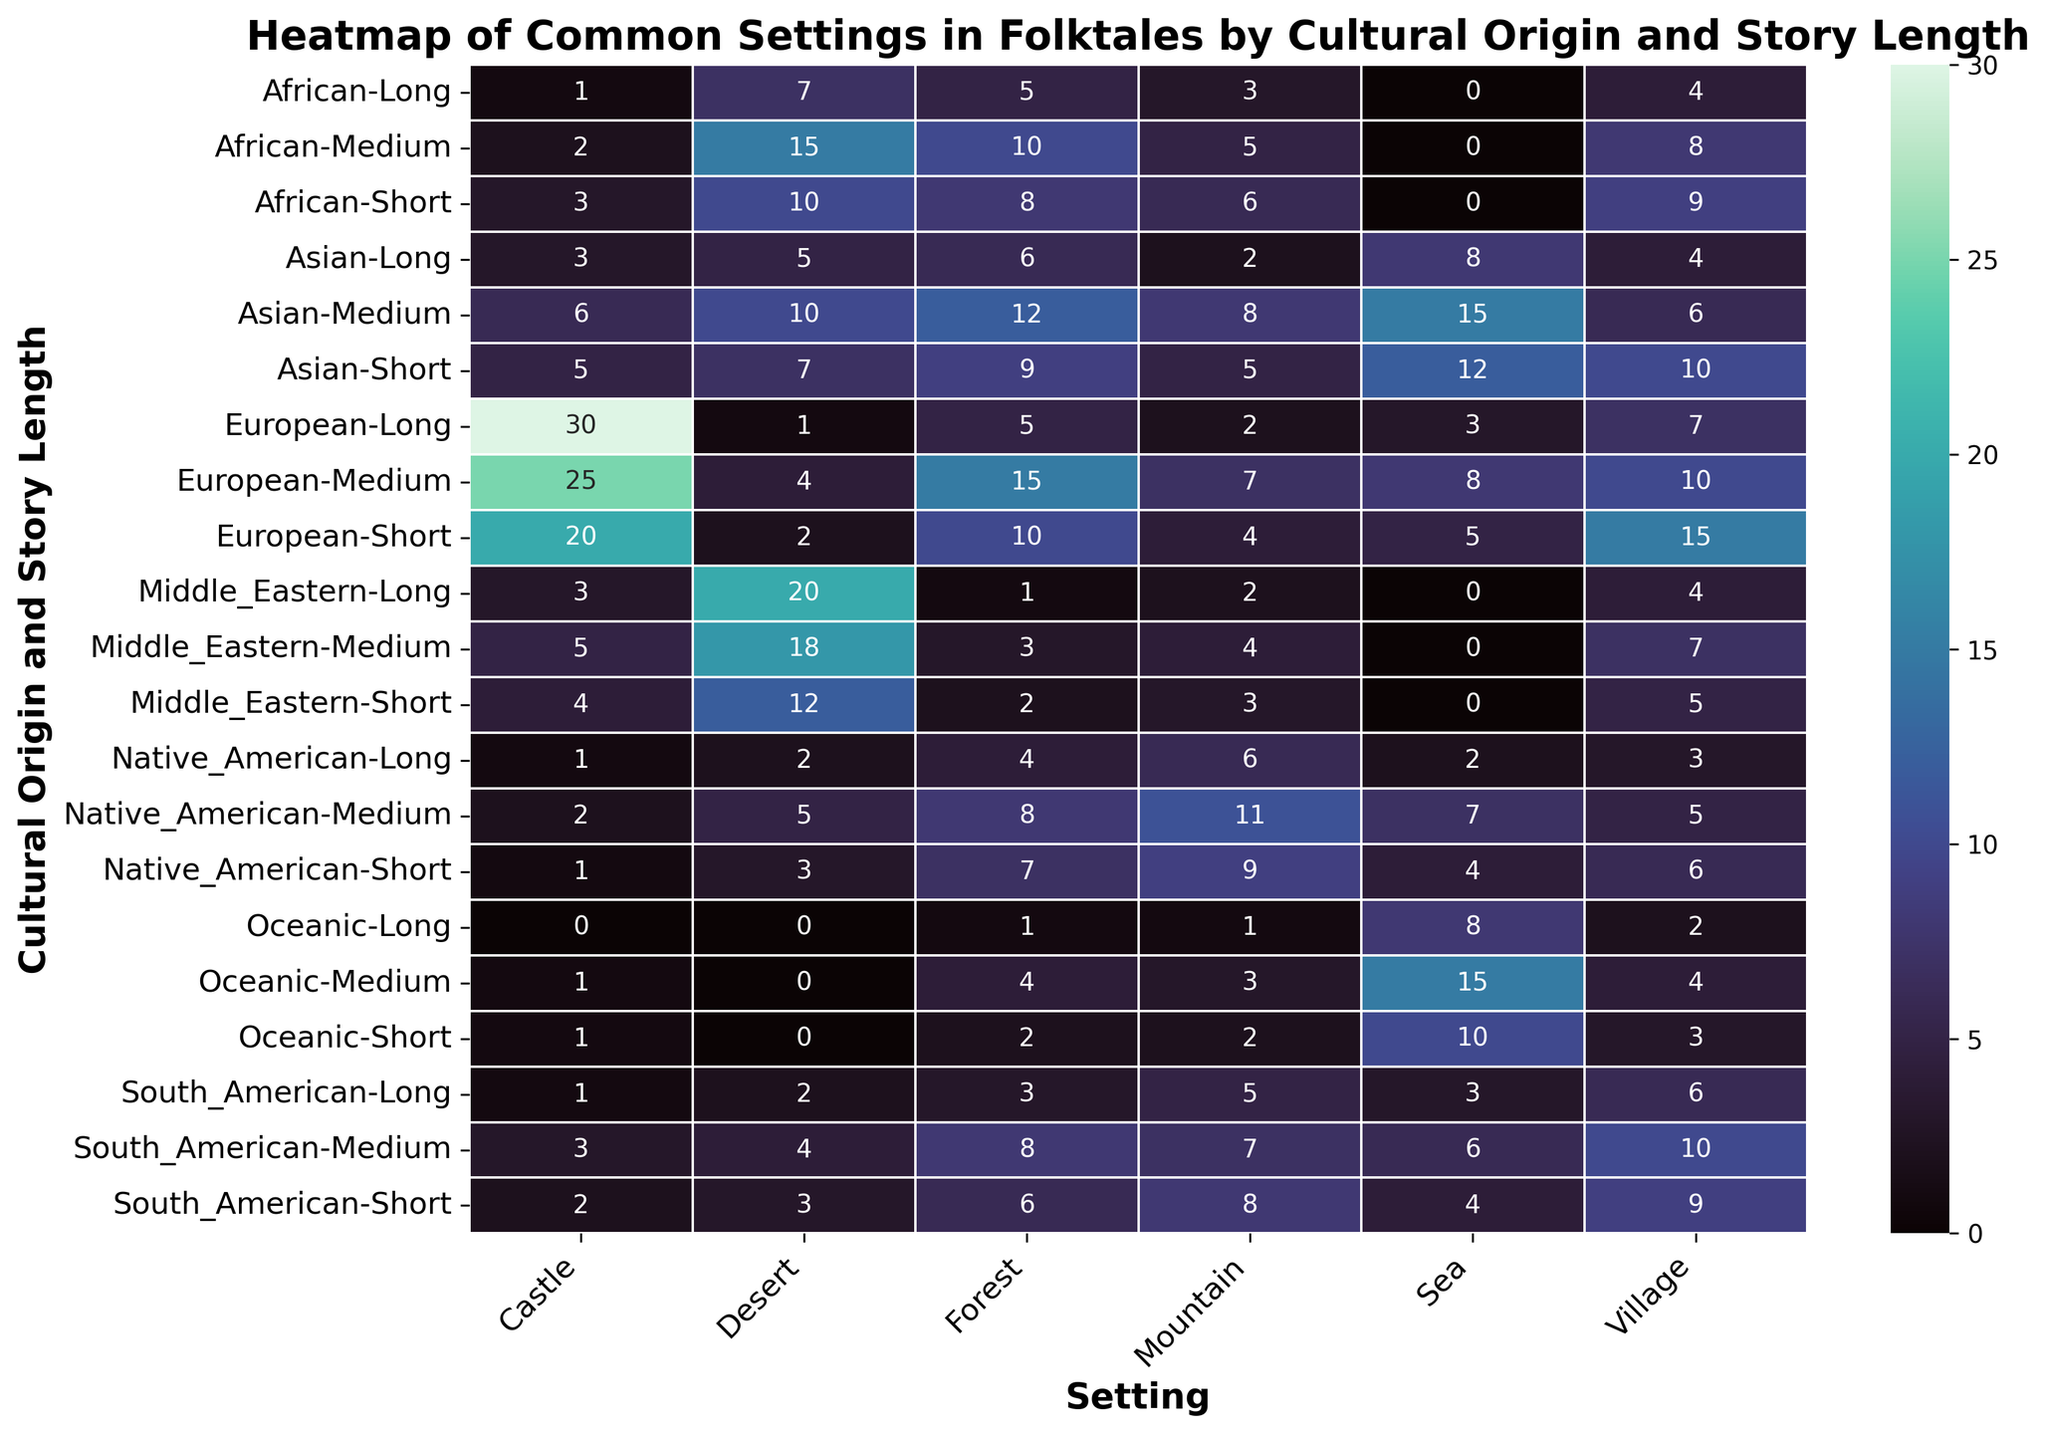Which cultural origin has the highest count of folktales set in castles for long stories? To find the answer, look in the column for "Castle" and the rows representing long stories. Look for the highest number. European long stories have 30, which is the highest in that column.
Answer: European Which cultural origin and story length combination has the most folktales set in forests? Look down the "Forest" column to find the highest value and check the corresponding row. The highest count is 15 in European medium-length stories.
Answer: European, Medium Compare the folktales set in the desert for Asian medium stories and African medium stories. Which has a higher count and by how much? Find the rows for Asian and African cultural origins with medium story lengths and compare the values in the "Desert" column. Asian medium stories have 10, while African medium stories have 15. 15 is higher than 10 by 5.
Answer: African by 5 What's the combined count of folktales set in villages for Middle Eastern short and medium stories? Locate the values for Middle Eastern short (5) and medium stories (7) in the "Village" column and add these two values together. 5 + 7 = 12.
Answer: 12 How does the count of folktales set in seas compare between Native American medium stories and Oceanic medium stories? Compare the values in the "Sea" column for Native American medium (7) and Oceanic medium (15) stories. Oceanic medium stories have a higher count by 8.
Answer: Oceanic by 8 What is the average count of folktales set in deserts across all short stories? Add the values in the "Desert" column for all short stories (European: 2, Asian: 7, African: 10, Native American: 3, Middle Eastern: 12, South American: 3, Oceanic: 0) and divide by the number of short story data points (7). The sum is 37, and the average is 37 / 7 ≈ 5.29.
Answer: 5.29 Which setting is most common in South American folktales of all story lengths? Look at the row for South American folktales and compare values across all settings (Forest, Mountain, Village, Castle, Sea, Desert). The highest count is for "Village" with 10 in the medium-length stories.
Answer: Village Are there any cultural origins that have no folktales set in the sea for any story length? Check the "Sea" column for any zeros across all story lengths for each cultural origin. African stories have a count of 0 in all story lengths.
Answer: African What is the sum of folktales set in mountains for Native American short and long stories? Identify and add the values in the "Mountain" column for Native American short (9) and long (6) stories. 9 + 6 = 15.
Answer: 15 